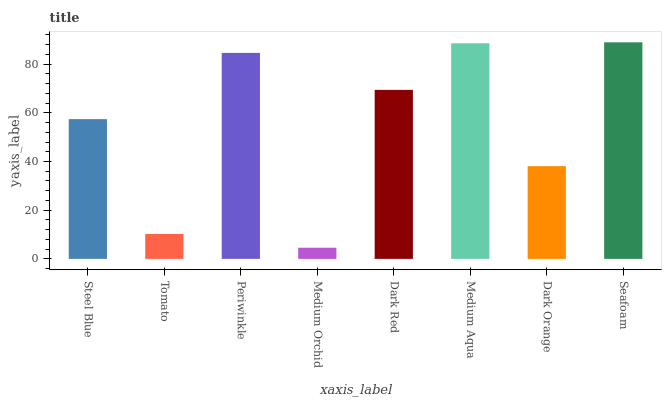Is Medium Orchid the minimum?
Answer yes or no. Yes. Is Seafoam the maximum?
Answer yes or no. Yes. Is Tomato the minimum?
Answer yes or no. No. Is Tomato the maximum?
Answer yes or no. No. Is Steel Blue greater than Tomato?
Answer yes or no. Yes. Is Tomato less than Steel Blue?
Answer yes or no. Yes. Is Tomato greater than Steel Blue?
Answer yes or no. No. Is Steel Blue less than Tomato?
Answer yes or no. No. Is Dark Red the high median?
Answer yes or no. Yes. Is Steel Blue the low median?
Answer yes or no. Yes. Is Tomato the high median?
Answer yes or no. No. Is Periwinkle the low median?
Answer yes or no. No. 